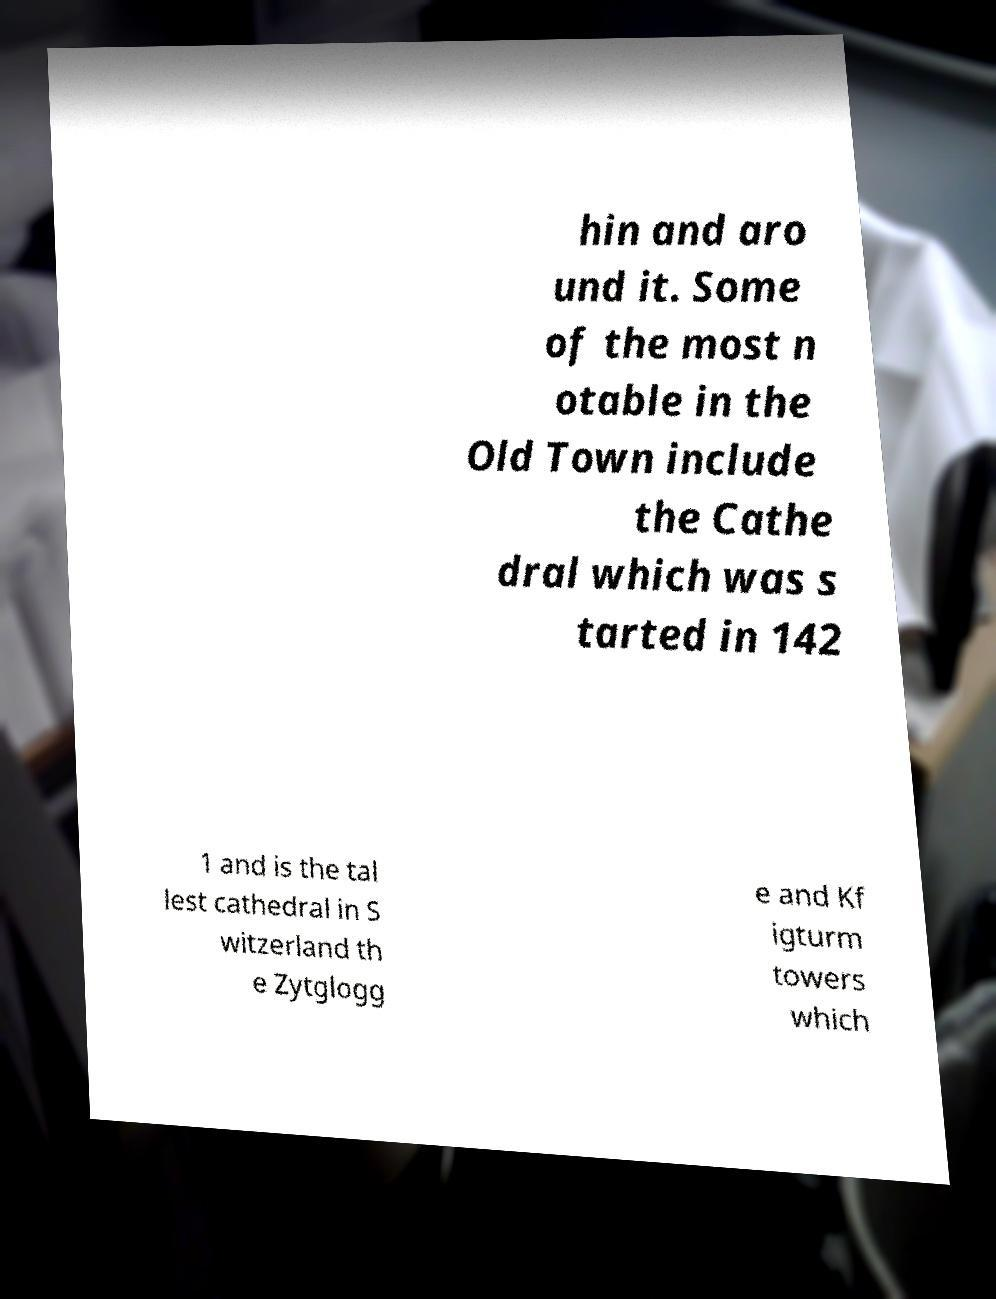Could you assist in decoding the text presented in this image and type it out clearly? hin and aro und it. Some of the most n otable in the Old Town include the Cathe dral which was s tarted in 142 1 and is the tal lest cathedral in S witzerland th e Zytglogg e and Kf igturm towers which 